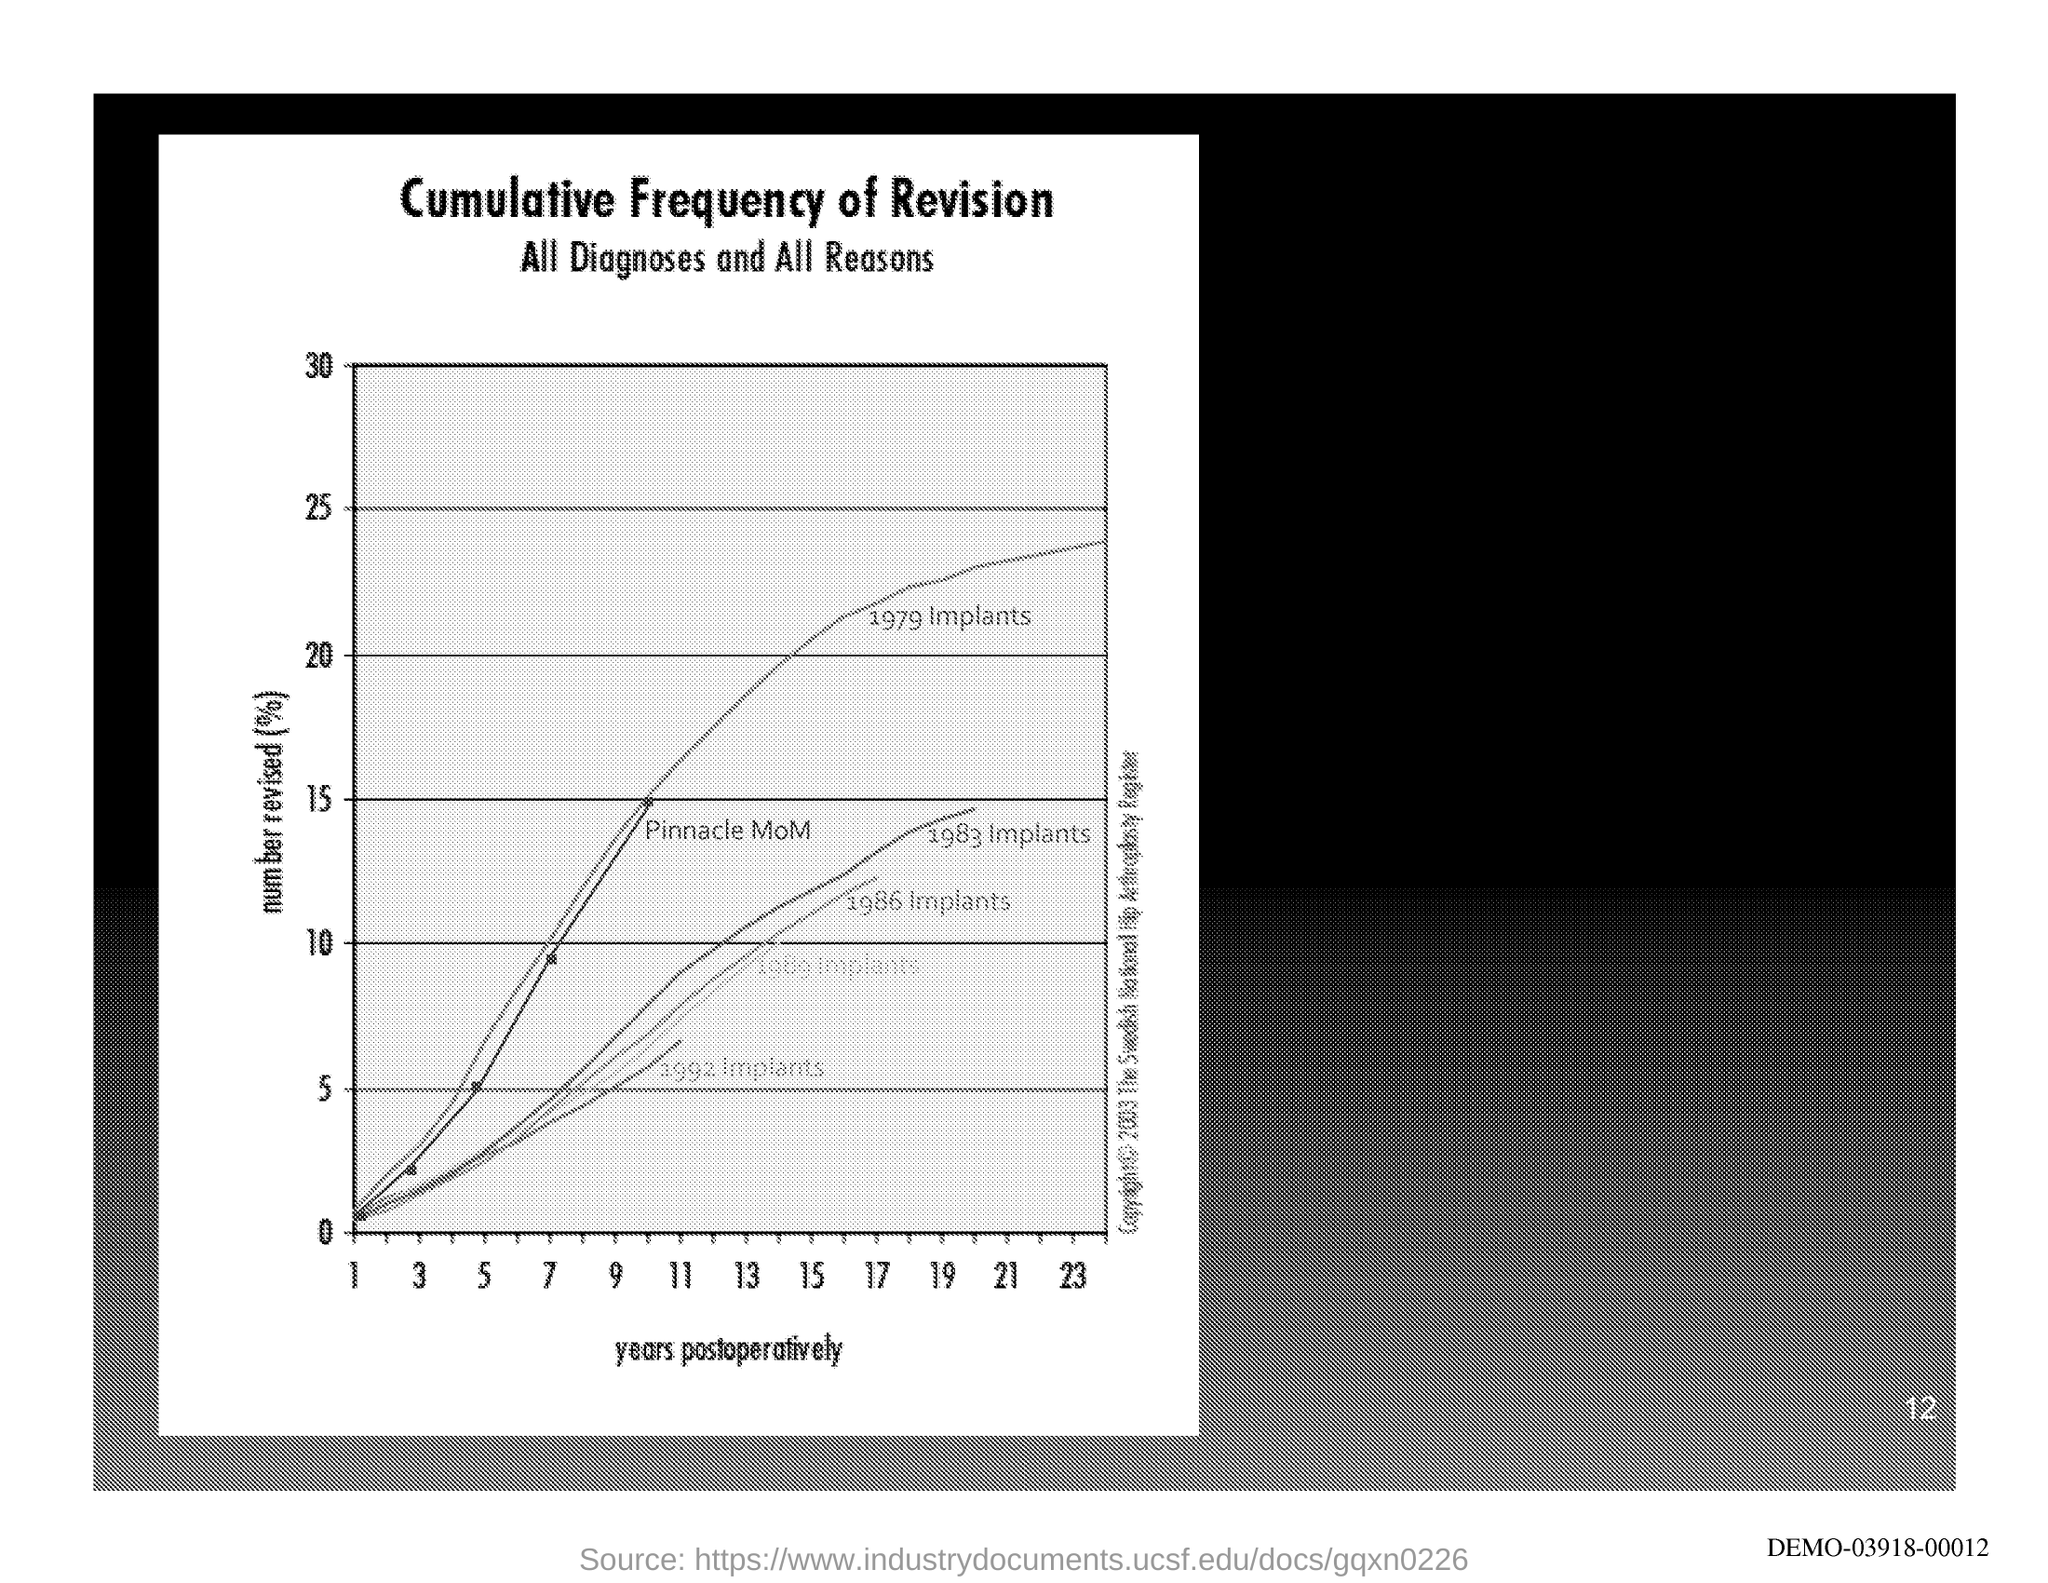Draw attention to some important aspects in this diagram. The years postoperatively are plotted on the x-axis. The document's first title is "Cumulative Frequency of Revision. The page number is 12, as declared. The document contains the second title "All Diagnoses and All Reasons. 